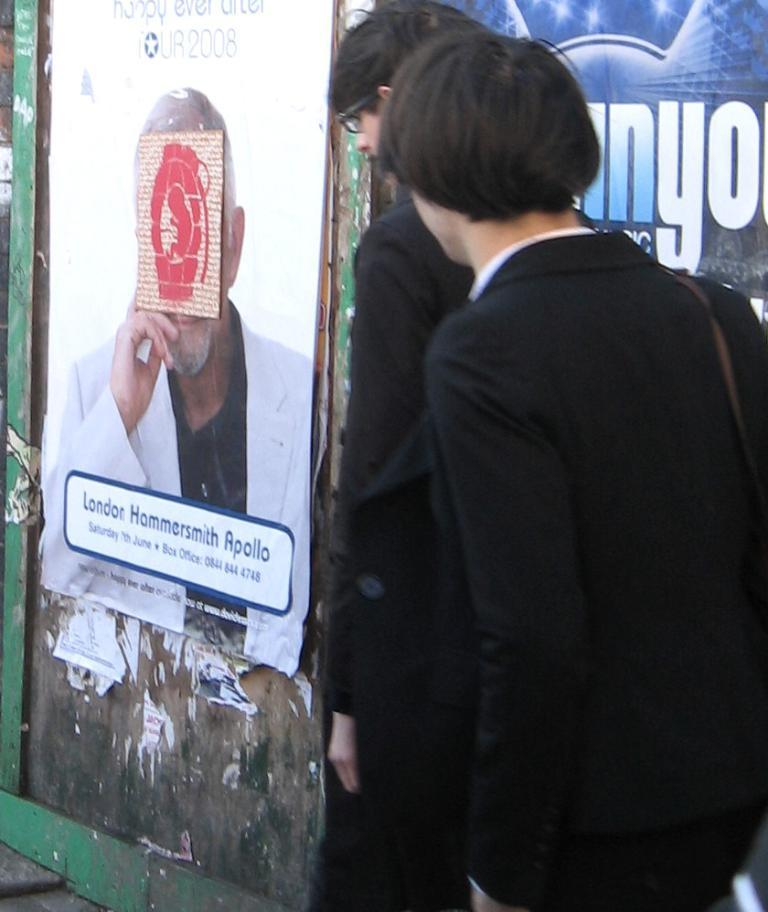How many people are present in the image? There are two people in the image. What are the people wearing? Both people are wearing clothes. Can you describe any accessories worn by the people? One person is wearing spectacles. What can be seen on the wall in the image? There is a poster on the wall. What is visible in the image that might be used for communication? There is text visible in the image. What type of surface is present in the image? There is a wall and a footpath in the image. What type of glue is being used by the women in the image? There are no women present in the image, and no glue is visible. How does the nerve affect the person's ability to walk in the image? There is no mention of a nerve or any walking-related issues in the image. 